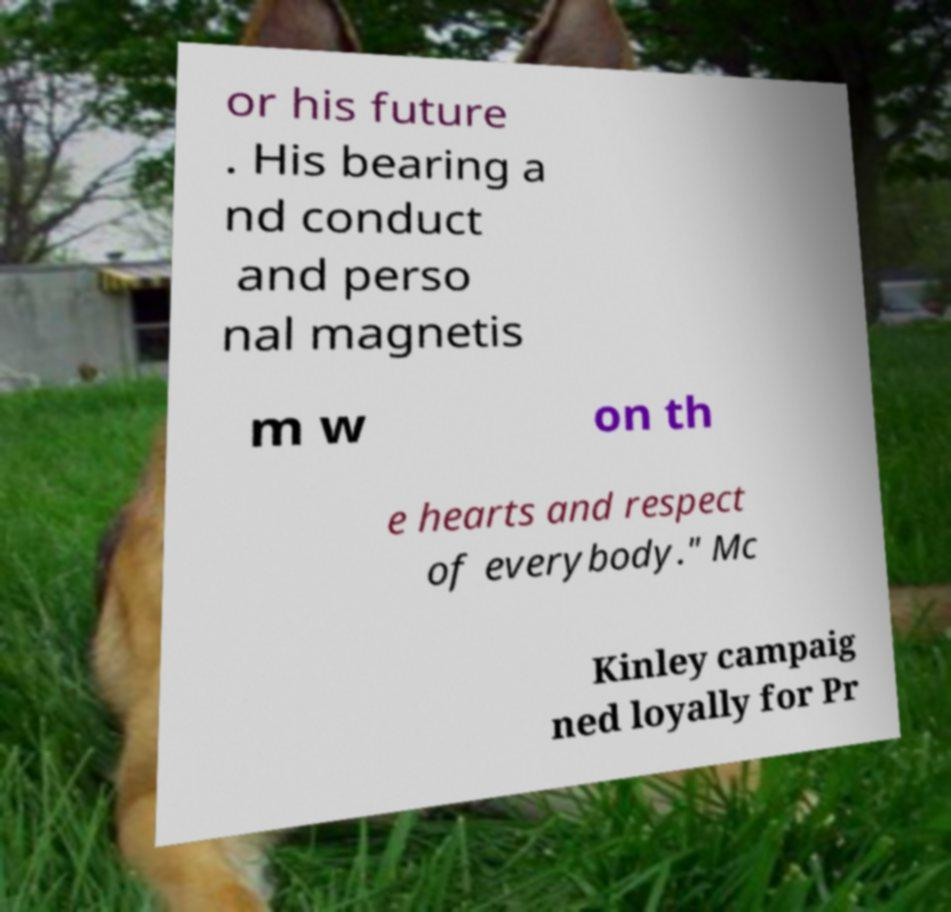What messages or text are displayed in this image? I need them in a readable, typed format. or his future . His bearing a nd conduct and perso nal magnetis m w on th e hearts and respect of everybody." Mc Kinley campaig ned loyally for Pr 